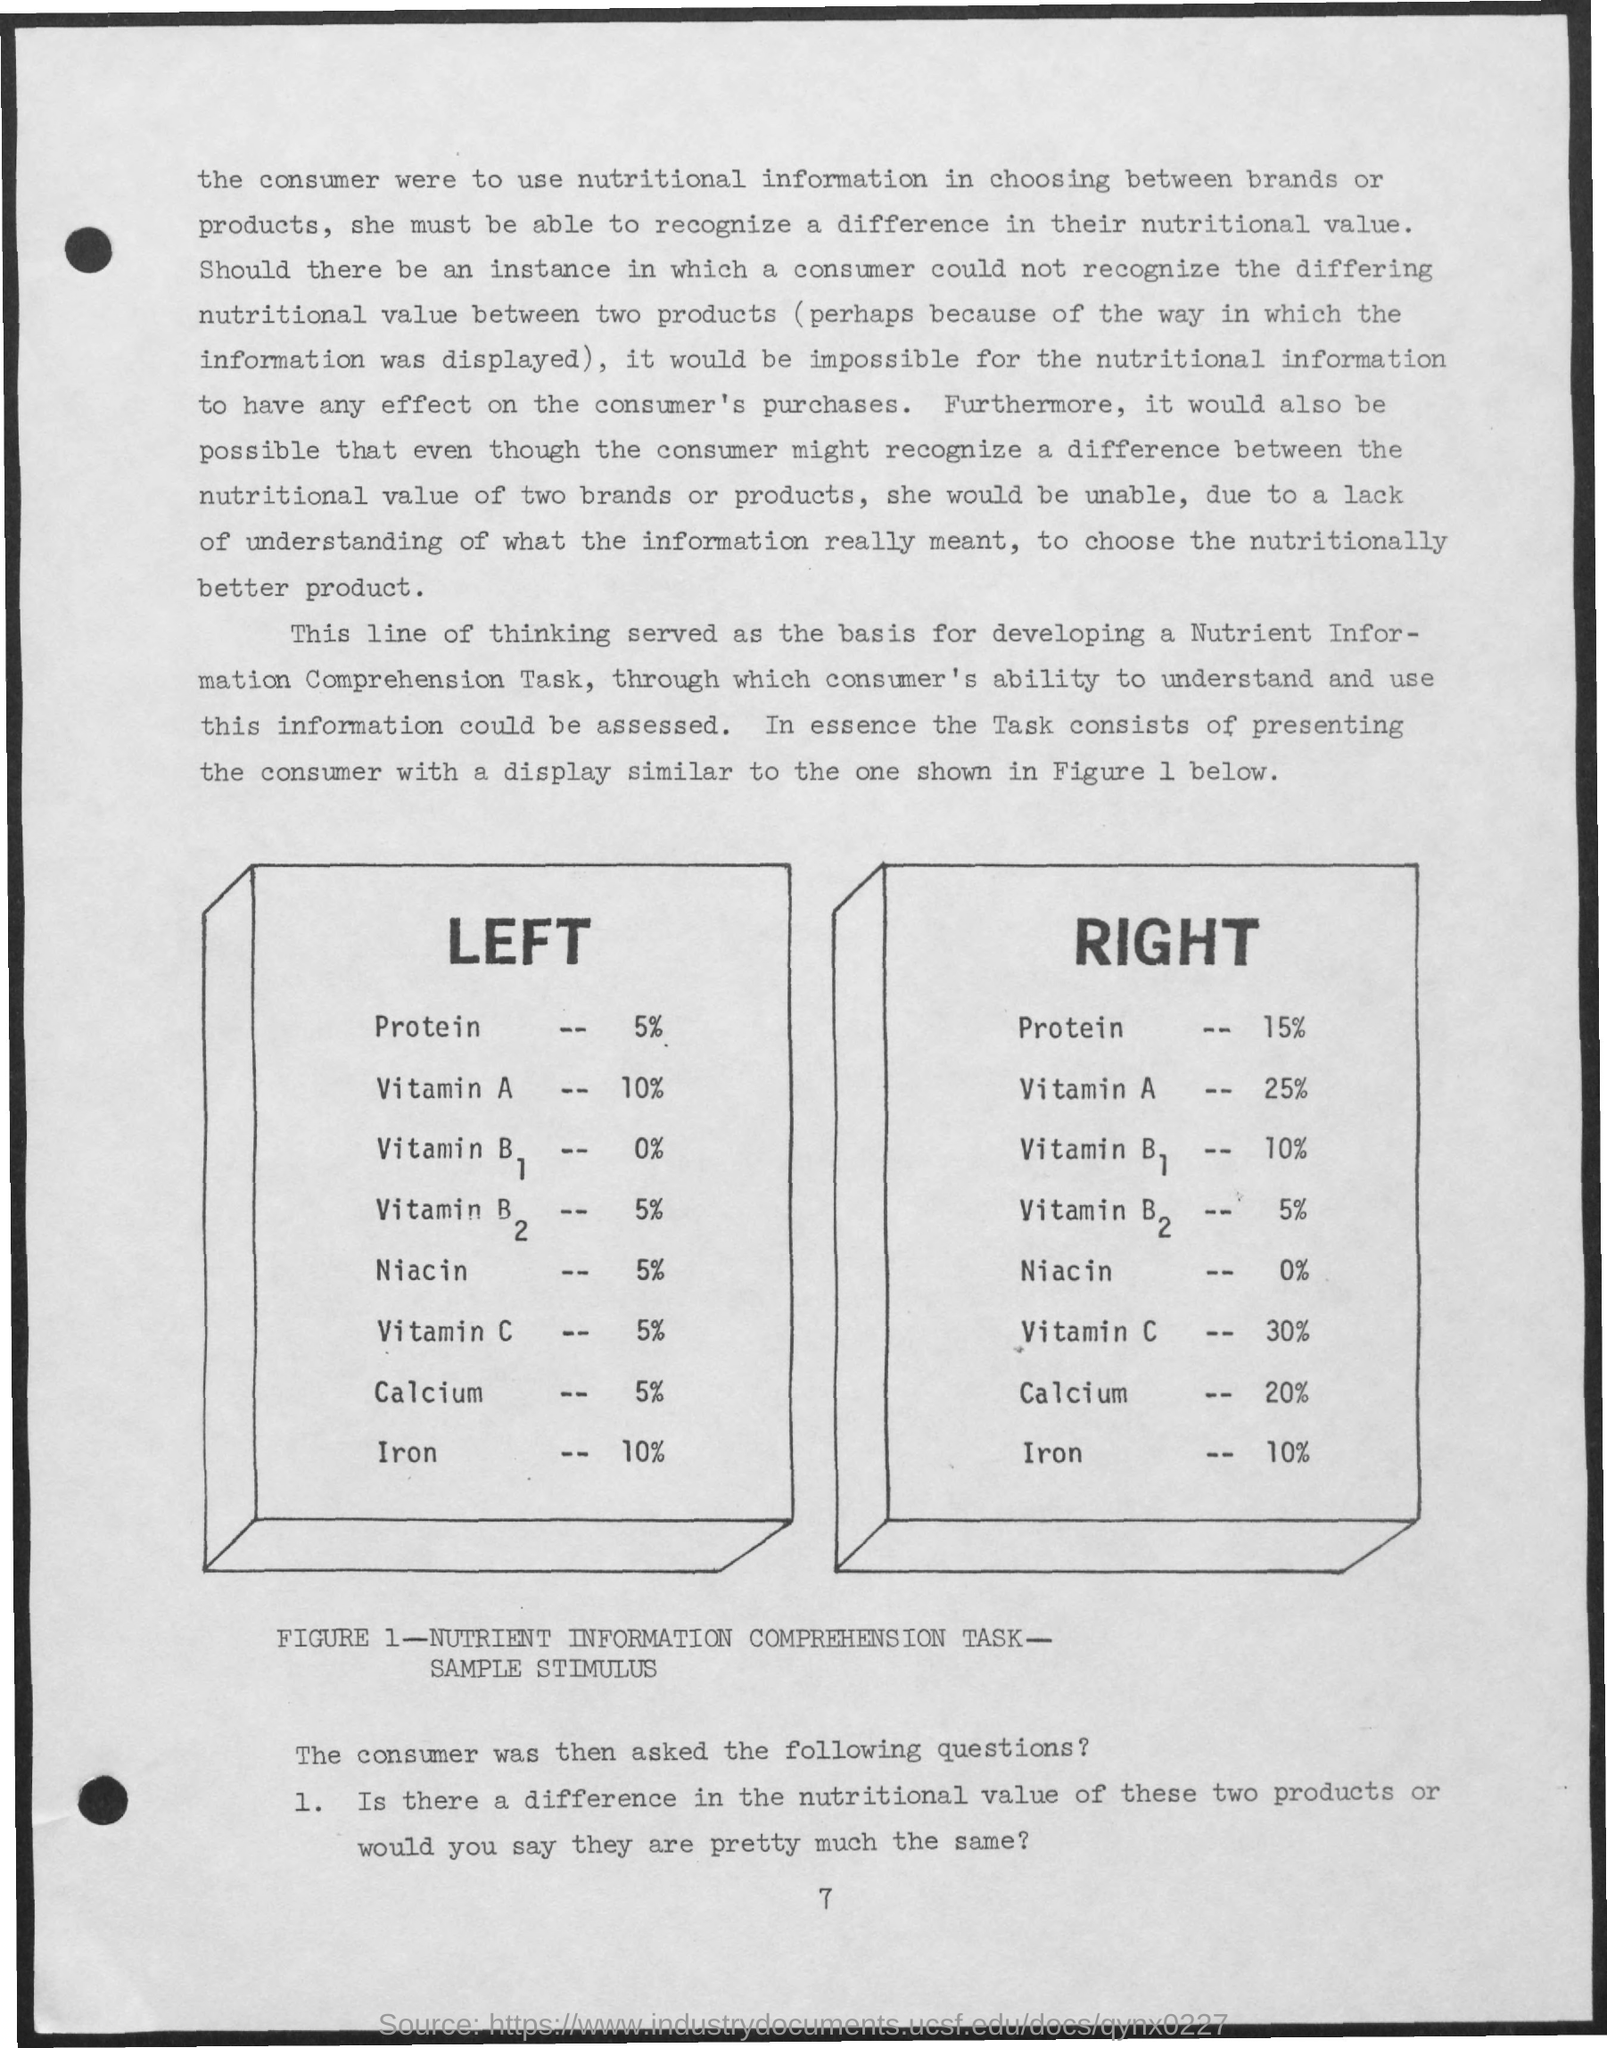What is the Page Number?
Provide a short and direct response. 7. What is the figure number?
Make the answer very short. 1. What is the percentage of protein on the left?
Your answer should be very brief. 5%. What is the percentage of calcium on the right?
Offer a terse response. 20%. What is the percentage of niacin on the right?
Give a very brief answer. 0%. What is the percentage of iron on the right?
Provide a short and direct response. 10%. 